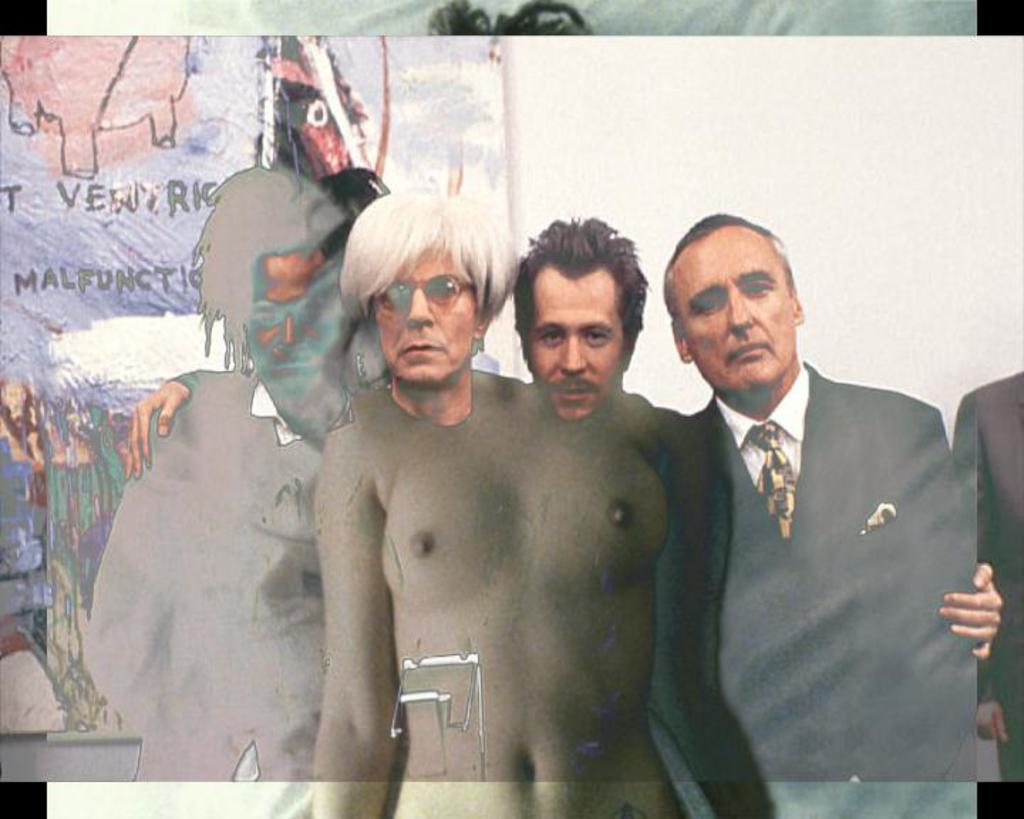What is the main subject of the image? The main subject of the image is a person. What is the person holding in the image? The person is holding a photo frame. How is the person holding the photo frame? The person is holding the photo frame from the backside. What type of tax is being discussed in the image? There is no discussion of tax in the image; it features a person holding a photo frame from the backside. How many spoons are visible in the image? There are no spoons visible in the image. 